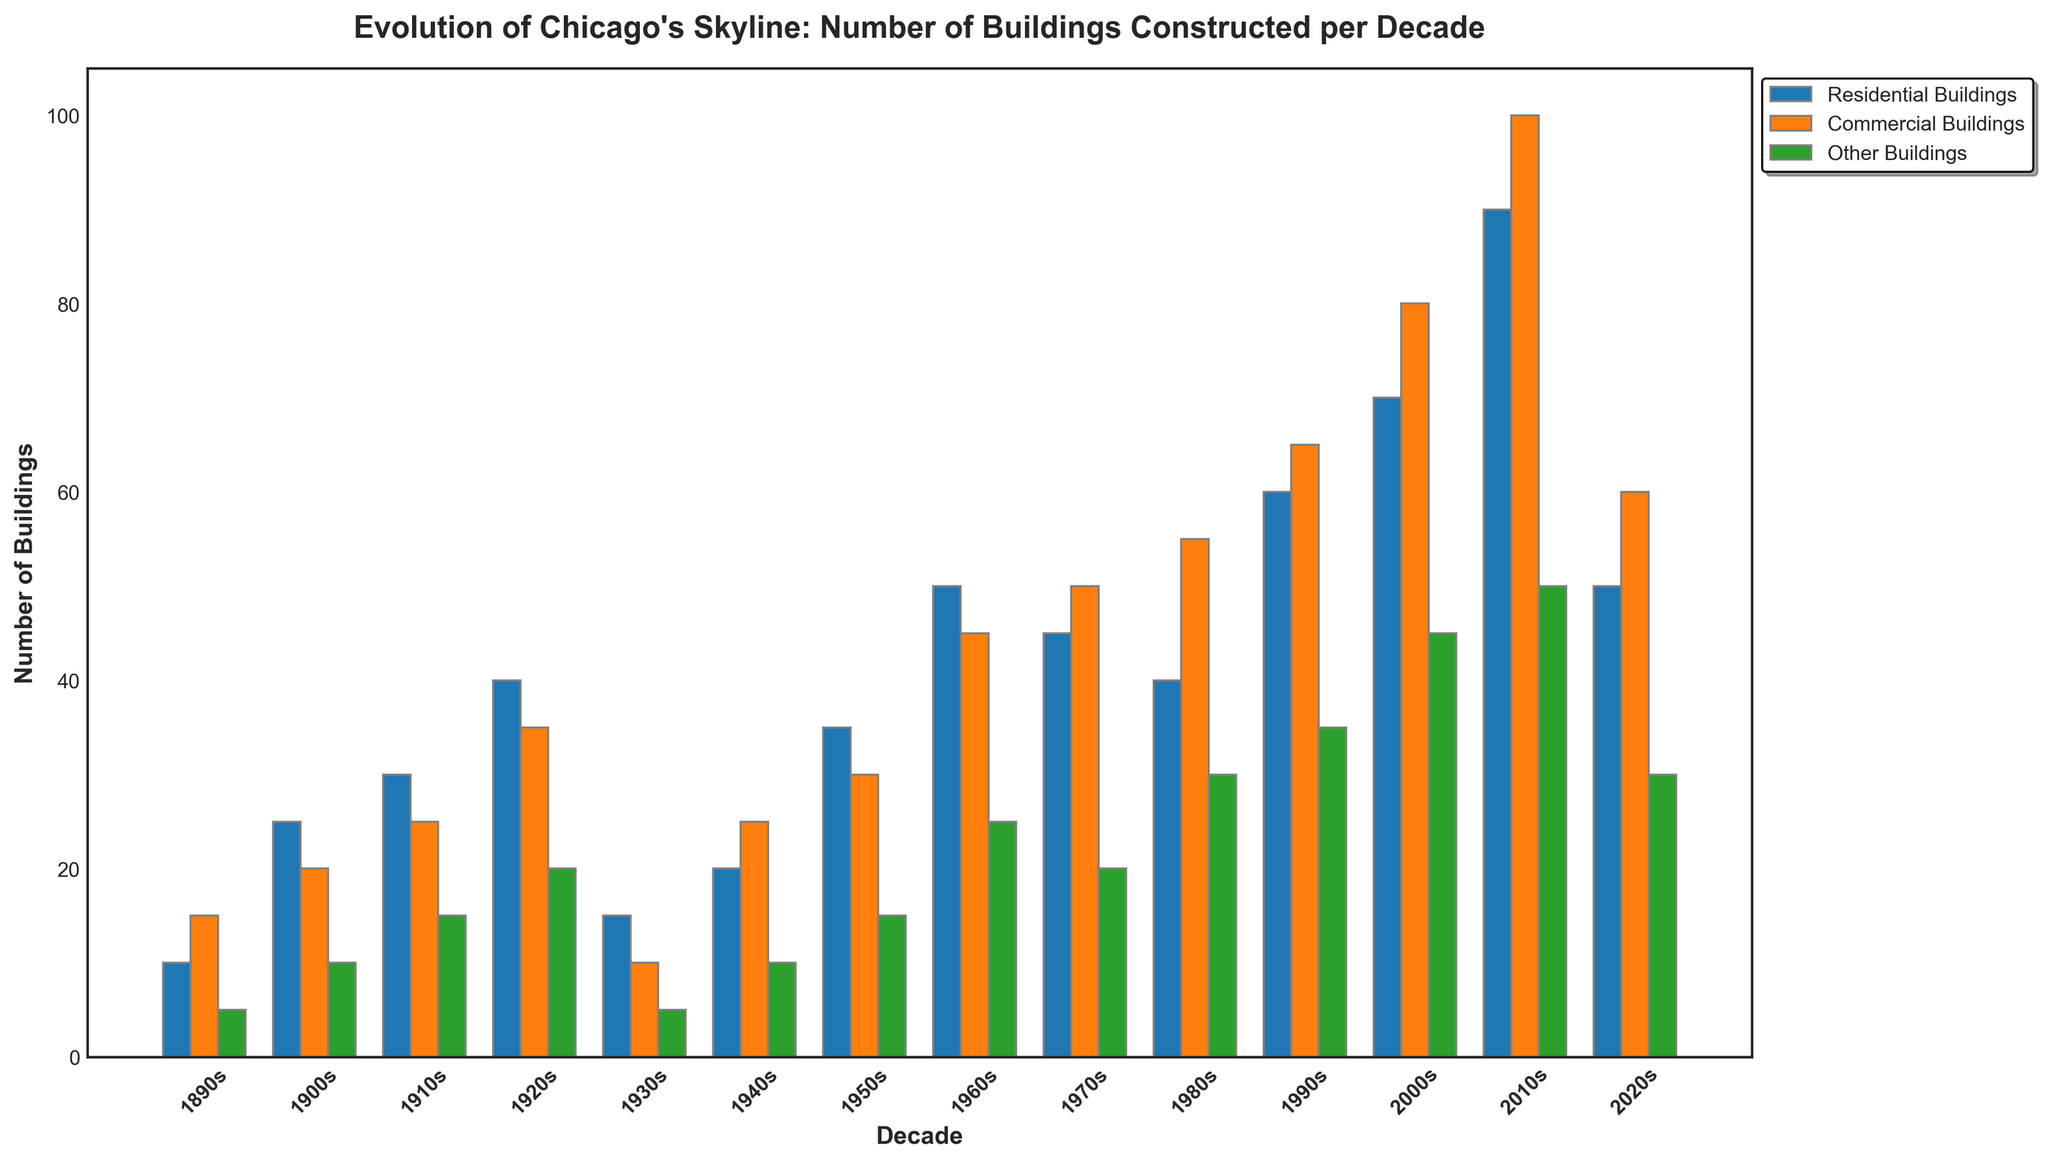Which decade had the highest number of residential buildings constructed? The decade with the tallest blue bar represents the decade with the highest number of residential buildings constructed, which is the 2010s with 90 residential buildings.
Answer: 2010s How many commercial buildings were constructed in the 1940s and 1950s combined? To find the total number of commercial buildings constructed in both decades, sum the values for the 1940s and 1950s from the orange bars: 25 (1940s) + 30 (1950s) = 55.
Answer: 55 Which category had the least number of buildings constructed in the 1930s? Compare the heights of the three bars for the 1930s. The green bar is the shortest, so "Other Buildings" had the least number of buildings constructed.
Answer: Other Buildings What is the difference between the number of residential buildings constructed in the 2000s and the 2020s? Subtract the number of residential buildings in the 2020s from the number in the 2000s: 70 (2000s) - 50 (2020s) = 20.
Answer: 20 During which decade did the construction of commercial buildings peak? Identify the decade with the tallest orange bar, which is the 2010s with 100 commercial buildings.
Answer: 2010s What is the total number of buildings constructed in the 1910s? Sum the heights of the blue, orange, and green bars for the 1910s: 30 (Residential) + 25 (Commercial) + 15 (Other) = 70.
Answer: 70 Which decade had more "Other Buildings" constructed: the 1970s or the 2000s? Compare the heights of the green bars for the 1970s and the 2000s. The 2000s had more with 45 "Other Buildings" compared to 20 in the 1970s.
Answer: 2000s What is the average number of commercial buildings constructed per decade from the 1890s to the 2010s? Add the number of commercial buildings constructed each decade and divide by the number of decades: (15+20+25+35+10+25+30+45+50+55+65+80+100) / 13 ≈ 41.
Answer: 41 How many more residential buildings were constructed in the 2010s compared to the 1960s? Subtract the number of residential buildings in the 1960s from the number in the 2010s: 90 (2010s) - 50 (1960s) = 40.
Answer: 40 Which type of building showed the least growth comparing the 2010s to the 2000s? Calculate the difference for each category: Residential (90-70=20), Commercial (100-80=20), Other (50-45=5). The least growth is in "Other Buildings" with a difference of 5.
Answer: Other Buildings 